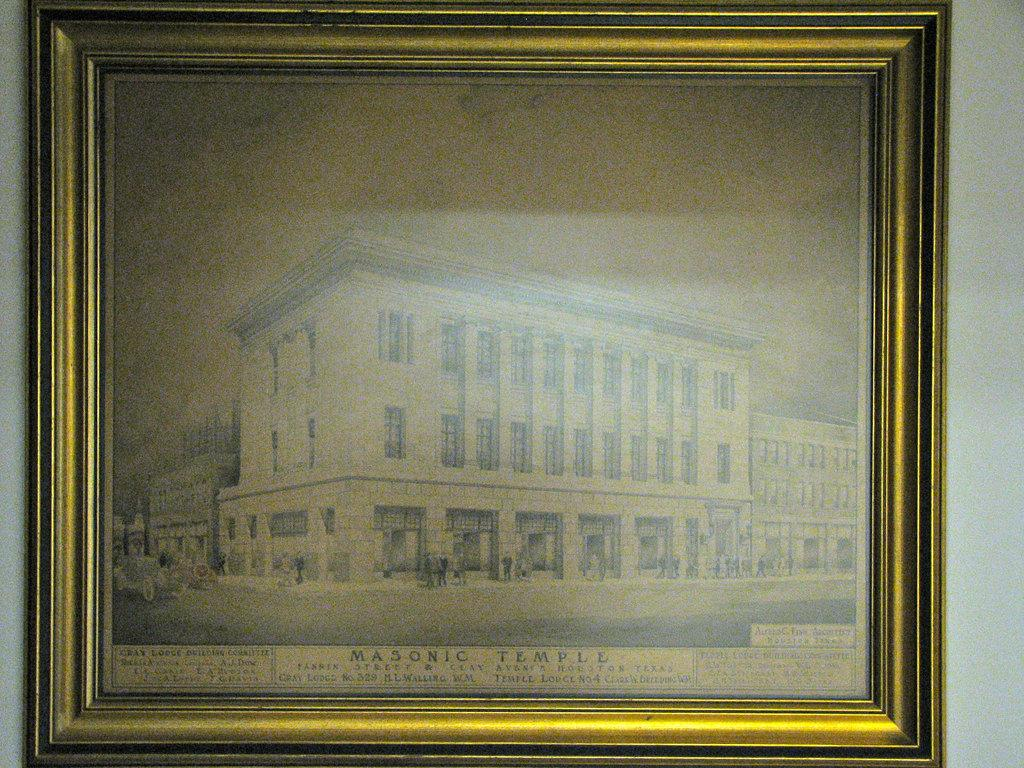What is the main subject of the image? The main subject of the image is a frame. What is depicted within the frame? The frame contains a building. Are there any other elements visible in the image? Yes, there are people visible in the image. What degree do the people in the image have? There is no information about the people's degrees in the image. What type of transport is being used by the people in the image? There is no information about the people using any transport in the image. 